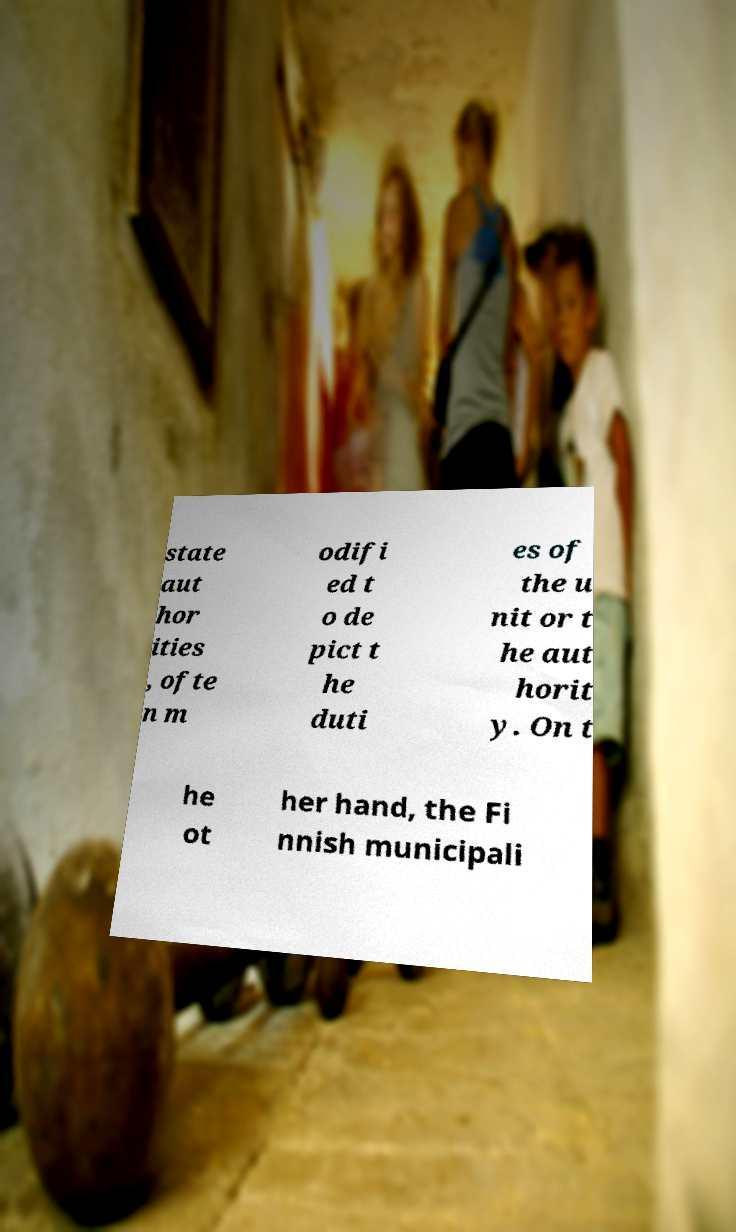I need the written content from this picture converted into text. Can you do that? state aut hor ities , ofte n m odifi ed t o de pict t he duti es of the u nit or t he aut horit y. On t he ot her hand, the Fi nnish municipali 